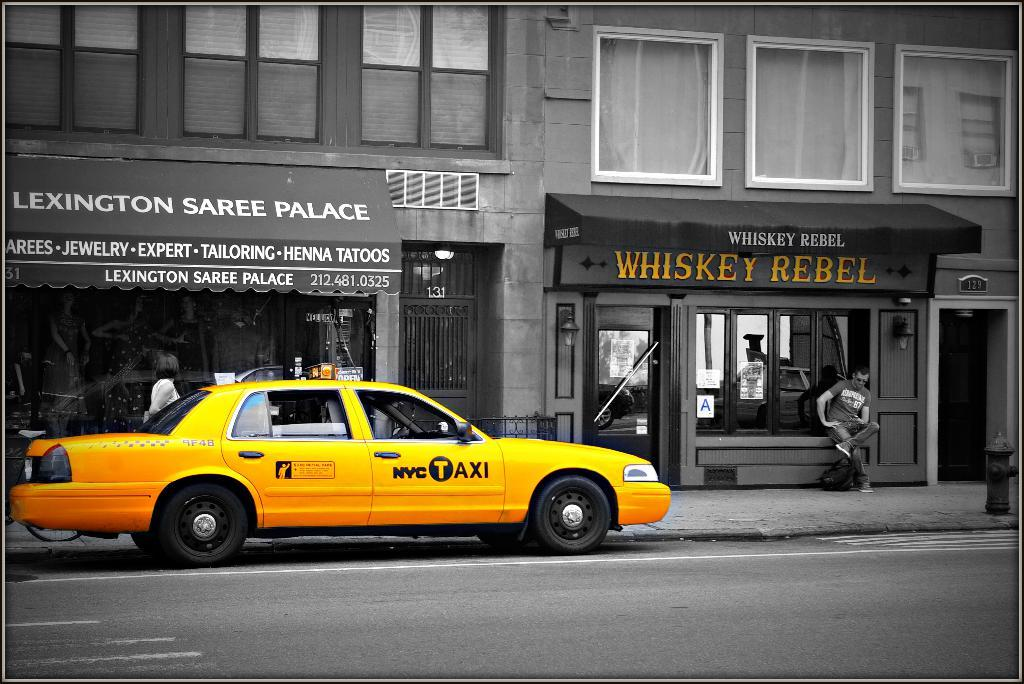<image>
Share a concise interpretation of the image provided. a yellow NYC Taxi parked in front of Lexington Saree Palace and Whiskey Rebel 